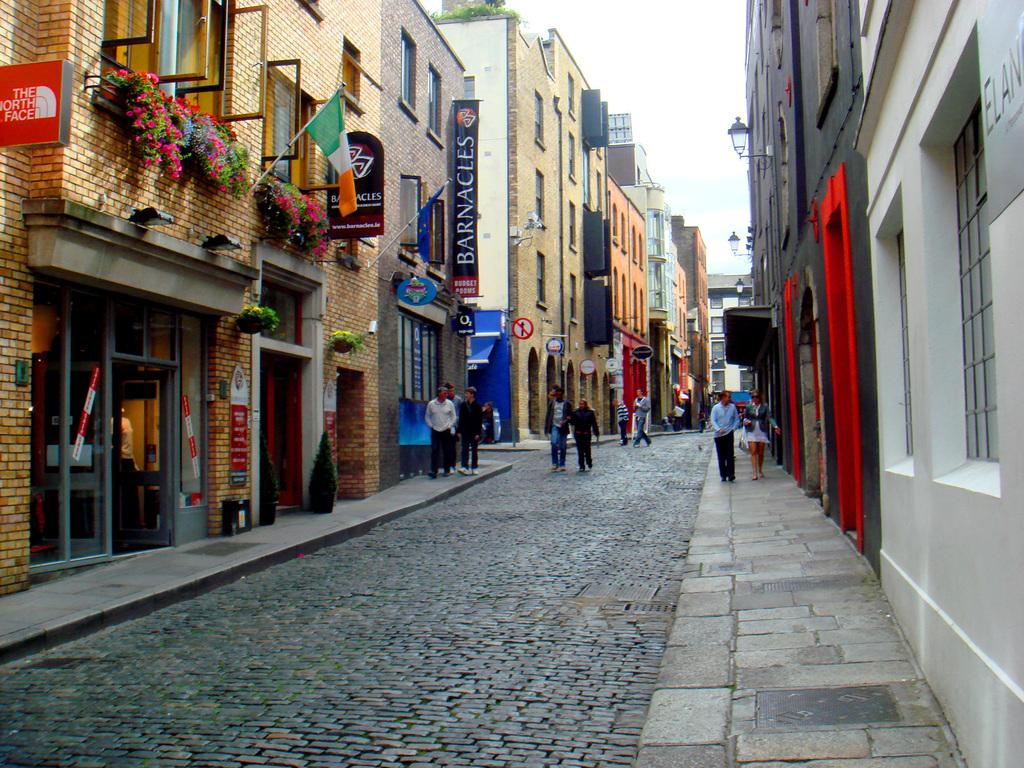What is happening in the image? There are people standing in the image. What can be seen in the background behind the people? There are buildings on either side of the people. What type of heat source can be seen in the image? There is no heat source visible in the image. What color is the light emitted by the frame in the image? There is no frame or light source present in the image. 